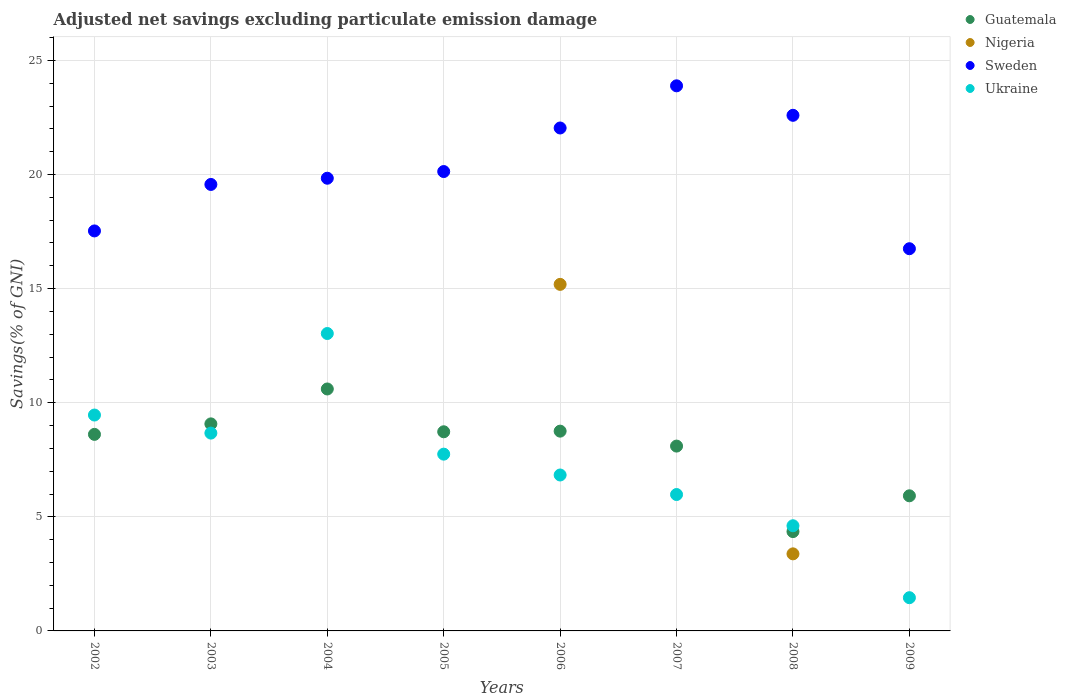Is the number of dotlines equal to the number of legend labels?
Offer a terse response. No. What is the adjusted net savings in Ukraine in 2009?
Your answer should be compact. 1.46. Across all years, what is the maximum adjusted net savings in Guatemala?
Ensure brevity in your answer.  10.6. Across all years, what is the minimum adjusted net savings in Sweden?
Your response must be concise. 16.75. In which year was the adjusted net savings in Sweden maximum?
Offer a very short reply. 2007. What is the total adjusted net savings in Sweden in the graph?
Keep it short and to the point. 162.33. What is the difference between the adjusted net savings in Sweden in 2006 and that in 2007?
Give a very brief answer. -1.85. What is the difference between the adjusted net savings in Nigeria in 2004 and the adjusted net savings in Guatemala in 2009?
Your answer should be very brief. -5.92. What is the average adjusted net savings in Sweden per year?
Ensure brevity in your answer.  20.29. In the year 2004, what is the difference between the adjusted net savings in Guatemala and adjusted net savings in Sweden?
Provide a short and direct response. -9.24. In how many years, is the adjusted net savings in Nigeria greater than 4 %?
Make the answer very short. 1. What is the ratio of the adjusted net savings in Sweden in 2003 to that in 2008?
Your answer should be very brief. 0.87. Is the adjusted net savings in Ukraine in 2003 less than that in 2008?
Offer a very short reply. No. What is the difference between the highest and the second highest adjusted net savings in Ukraine?
Give a very brief answer. 3.57. What is the difference between the highest and the lowest adjusted net savings in Ukraine?
Your answer should be compact. 11.58. In how many years, is the adjusted net savings in Guatemala greater than the average adjusted net savings in Guatemala taken over all years?
Give a very brief answer. 6. Is the adjusted net savings in Ukraine strictly greater than the adjusted net savings in Sweden over the years?
Offer a very short reply. No. How many years are there in the graph?
Your answer should be very brief. 8. What is the difference between two consecutive major ticks on the Y-axis?
Your response must be concise. 5. Does the graph contain any zero values?
Provide a short and direct response. Yes. Does the graph contain grids?
Ensure brevity in your answer.  Yes. Where does the legend appear in the graph?
Your answer should be very brief. Top right. What is the title of the graph?
Make the answer very short. Adjusted net savings excluding particulate emission damage. Does "High income: nonOECD" appear as one of the legend labels in the graph?
Your response must be concise. No. What is the label or title of the X-axis?
Provide a succinct answer. Years. What is the label or title of the Y-axis?
Provide a succinct answer. Savings(% of GNI). What is the Savings(% of GNI) of Guatemala in 2002?
Offer a very short reply. 8.61. What is the Savings(% of GNI) of Nigeria in 2002?
Provide a succinct answer. 0. What is the Savings(% of GNI) of Sweden in 2002?
Give a very brief answer. 17.53. What is the Savings(% of GNI) in Ukraine in 2002?
Your answer should be compact. 9.46. What is the Savings(% of GNI) of Guatemala in 2003?
Keep it short and to the point. 9.07. What is the Savings(% of GNI) in Sweden in 2003?
Your answer should be very brief. 19.57. What is the Savings(% of GNI) in Ukraine in 2003?
Give a very brief answer. 8.67. What is the Savings(% of GNI) of Guatemala in 2004?
Ensure brevity in your answer.  10.6. What is the Savings(% of GNI) in Sweden in 2004?
Provide a succinct answer. 19.84. What is the Savings(% of GNI) of Ukraine in 2004?
Your answer should be very brief. 13.03. What is the Savings(% of GNI) of Guatemala in 2005?
Provide a succinct answer. 8.73. What is the Savings(% of GNI) of Nigeria in 2005?
Your answer should be compact. 0. What is the Savings(% of GNI) of Sweden in 2005?
Offer a terse response. 20.13. What is the Savings(% of GNI) of Ukraine in 2005?
Provide a short and direct response. 7.75. What is the Savings(% of GNI) of Guatemala in 2006?
Ensure brevity in your answer.  8.75. What is the Savings(% of GNI) in Nigeria in 2006?
Offer a terse response. 15.19. What is the Savings(% of GNI) of Sweden in 2006?
Keep it short and to the point. 22.04. What is the Savings(% of GNI) in Ukraine in 2006?
Make the answer very short. 6.83. What is the Savings(% of GNI) in Guatemala in 2007?
Your response must be concise. 8.1. What is the Savings(% of GNI) of Nigeria in 2007?
Offer a very short reply. 0. What is the Savings(% of GNI) of Sweden in 2007?
Offer a terse response. 23.89. What is the Savings(% of GNI) of Ukraine in 2007?
Make the answer very short. 5.98. What is the Savings(% of GNI) in Guatemala in 2008?
Offer a terse response. 4.35. What is the Savings(% of GNI) in Nigeria in 2008?
Ensure brevity in your answer.  3.38. What is the Savings(% of GNI) of Sweden in 2008?
Your answer should be compact. 22.6. What is the Savings(% of GNI) of Ukraine in 2008?
Provide a short and direct response. 4.61. What is the Savings(% of GNI) of Guatemala in 2009?
Your answer should be compact. 5.92. What is the Savings(% of GNI) of Sweden in 2009?
Keep it short and to the point. 16.75. What is the Savings(% of GNI) in Ukraine in 2009?
Provide a short and direct response. 1.46. Across all years, what is the maximum Savings(% of GNI) in Guatemala?
Offer a very short reply. 10.6. Across all years, what is the maximum Savings(% of GNI) of Nigeria?
Make the answer very short. 15.19. Across all years, what is the maximum Savings(% of GNI) of Sweden?
Offer a terse response. 23.89. Across all years, what is the maximum Savings(% of GNI) of Ukraine?
Keep it short and to the point. 13.03. Across all years, what is the minimum Savings(% of GNI) of Guatemala?
Your answer should be very brief. 4.35. Across all years, what is the minimum Savings(% of GNI) of Sweden?
Provide a short and direct response. 16.75. Across all years, what is the minimum Savings(% of GNI) in Ukraine?
Offer a terse response. 1.46. What is the total Savings(% of GNI) of Guatemala in the graph?
Keep it short and to the point. 64.14. What is the total Savings(% of GNI) of Nigeria in the graph?
Offer a terse response. 18.56. What is the total Savings(% of GNI) of Sweden in the graph?
Your response must be concise. 162.33. What is the total Savings(% of GNI) of Ukraine in the graph?
Your answer should be compact. 57.78. What is the difference between the Savings(% of GNI) in Guatemala in 2002 and that in 2003?
Your answer should be very brief. -0.46. What is the difference between the Savings(% of GNI) in Sweden in 2002 and that in 2003?
Keep it short and to the point. -2.04. What is the difference between the Savings(% of GNI) in Ukraine in 2002 and that in 2003?
Your answer should be very brief. 0.79. What is the difference between the Savings(% of GNI) in Guatemala in 2002 and that in 2004?
Provide a succinct answer. -1.99. What is the difference between the Savings(% of GNI) of Sweden in 2002 and that in 2004?
Give a very brief answer. -2.31. What is the difference between the Savings(% of GNI) of Ukraine in 2002 and that in 2004?
Provide a succinct answer. -3.57. What is the difference between the Savings(% of GNI) in Guatemala in 2002 and that in 2005?
Give a very brief answer. -0.11. What is the difference between the Savings(% of GNI) of Sweden in 2002 and that in 2005?
Provide a short and direct response. -2.6. What is the difference between the Savings(% of GNI) of Ukraine in 2002 and that in 2005?
Offer a very short reply. 1.71. What is the difference between the Savings(% of GNI) of Guatemala in 2002 and that in 2006?
Offer a terse response. -0.14. What is the difference between the Savings(% of GNI) in Sweden in 2002 and that in 2006?
Make the answer very short. -4.51. What is the difference between the Savings(% of GNI) in Ukraine in 2002 and that in 2006?
Provide a short and direct response. 2.63. What is the difference between the Savings(% of GNI) in Guatemala in 2002 and that in 2007?
Provide a succinct answer. 0.51. What is the difference between the Savings(% of GNI) of Sweden in 2002 and that in 2007?
Your response must be concise. -6.36. What is the difference between the Savings(% of GNI) of Ukraine in 2002 and that in 2007?
Keep it short and to the point. 3.48. What is the difference between the Savings(% of GNI) of Guatemala in 2002 and that in 2008?
Your response must be concise. 4.26. What is the difference between the Savings(% of GNI) of Sweden in 2002 and that in 2008?
Offer a terse response. -5.07. What is the difference between the Savings(% of GNI) of Ukraine in 2002 and that in 2008?
Your answer should be very brief. 4.85. What is the difference between the Savings(% of GNI) of Guatemala in 2002 and that in 2009?
Your answer should be very brief. 2.69. What is the difference between the Savings(% of GNI) of Sweden in 2002 and that in 2009?
Your response must be concise. 0.78. What is the difference between the Savings(% of GNI) of Ukraine in 2002 and that in 2009?
Provide a succinct answer. 8. What is the difference between the Savings(% of GNI) in Guatemala in 2003 and that in 2004?
Give a very brief answer. -1.53. What is the difference between the Savings(% of GNI) in Sweden in 2003 and that in 2004?
Offer a terse response. -0.27. What is the difference between the Savings(% of GNI) of Ukraine in 2003 and that in 2004?
Offer a terse response. -4.36. What is the difference between the Savings(% of GNI) of Guatemala in 2003 and that in 2005?
Provide a short and direct response. 0.35. What is the difference between the Savings(% of GNI) in Sweden in 2003 and that in 2005?
Provide a succinct answer. -0.57. What is the difference between the Savings(% of GNI) of Ukraine in 2003 and that in 2005?
Your response must be concise. 0.92. What is the difference between the Savings(% of GNI) of Guatemala in 2003 and that in 2006?
Offer a terse response. 0.32. What is the difference between the Savings(% of GNI) of Sweden in 2003 and that in 2006?
Your answer should be very brief. -2.47. What is the difference between the Savings(% of GNI) of Ukraine in 2003 and that in 2006?
Provide a short and direct response. 1.84. What is the difference between the Savings(% of GNI) in Guatemala in 2003 and that in 2007?
Keep it short and to the point. 0.97. What is the difference between the Savings(% of GNI) in Sweden in 2003 and that in 2007?
Give a very brief answer. -4.32. What is the difference between the Savings(% of GNI) in Ukraine in 2003 and that in 2007?
Your answer should be compact. 2.69. What is the difference between the Savings(% of GNI) in Guatemala in 2003 and that in 2008?
Your response must be concise. 4.72. What is the difference between the Savings(% of GNI) of Sweden in 2003 and that in 2008?
Your answer should be very brief. -3.03. What is the difference between the Savings(% of GNI) of Ukraine in 2003 and that in 2008?
Offer a very short reply. 4.06. What is the difference between the Savings(% of GNI) in Guatemala in 2003 and that in 2009?
Provide a short and direct response. 3.15. What is the difference between the Savings(% of GNI) of Sweden in 2003 and that in 2009?
Your answer should be compact. 2.82. What is the difference between the Savings(% of GNI) in Ukraine in 2003 and that in 2009?
Your response must be concise. 7.21. What is the difference between the Savings(% of GNI) in Guatemala in 2004 and that in 2005?
Make the answer very short. 1.88. What is the difference between the Savings(% of GNI) in Sweden in 2004 and that in 2005?
Your answer should be very brief. -0.29. What is the difference between the Savings(% of GNI) of Ukraine in 2004 and that in 2005?
Provide a short and direct response. 5.29. What is the difference between the Savings(% of GNI) in Guatemala in 2004 and that in 2006?
Give a very brief answer. 1.85. What is the difference between the Savings(% of GNI) of Sweden in 2004 and that in 2006?
Offer a terse response. -2.2. What is the difference between the Savings(% of GNI) in Ukraine in 2004 and that in 2006?
Give a very brief answer. 6.2. What is the difference between the Savings(% of GNI) of Guatemala in 2004 and that in 2007?
Your answer should be compact. 2.5. What is the difference between the Savings(% of GNI) in Sweden in 2004 and that in 2007?
Ensure brevity in your answer.  -4.05. What is the difference between the Savings(% of GNI) in Ukraine in 2004 and that in 2007?
Your response must be concise. 7.06. What is the difference between the Savings(% of GNI) in Guatemala in 2004 and that in 2008?
Your response must be concise. 6.25. What is the difference between the Savings(% of GNI) in Sweden in 2004 and that in 2008?
Offer a very short reply. -2.76. What is the difference between the Savings(% of GNI) in Ukraine in 2004 and that in 2008?
Your answer should be very brief. 8.42. What is the difference between the Savings(% of GNI) in Guatemala in 2004 and that in 2009?
Your response must be concise. 4.68. What is the difference between the Savings(% of GNI) of Sweden in 2004 and that in 2009?
Ensure brevity in your answer.  3.09. What is the difference between the Savings(% of GNI) in Ukraine in 2004 and that in 2009?
Your answer should be very brief. 11.58. What is the difference between the Savings(% of GNI) in Guatemala in 2005 and that in 2006?
Your answer should be very brief. -0.03. What is the difference between the Savings(% of GNI) of Sweden in 2005 and that in 2006?
Keep it short and to the point. -1.91. What is the difference between the Savings(% of GNI) of Ukraine in 2005 and that in 2006?
Make the answer very short. 0.91. What is the difference between the Savings(% of GNI) of Guatemala in 2005 and that in 2007?
Provide a succinct answer. 0.63. What is the difference between the Savings(% of GNI) in Sweden in 2005 and that in 2007?
Make the answer very short. -3.76. What is the difference between the Savings(% of GNI) in Ukraine in 2005 and that in 2007?
Make the answer very short. 1.77. What is the difference between the Savings(% of GNI) in Guatemala in 2005 and that in 2008?
Your answer should be compact. 4.37. What is the difference between the Savings(% of GNI) of Sweden in 2005 and that in 2008?
Your response must be concise. -2.46. What is the difference between the Savings(% of GNI) of Ukraine in 2005 and that in 2008?
Your answer should be very brief. 3.14. What is the difference between the Savings(% of GNI) in Guatemala in 2005 and that in 2009?
Your response must be concise. 2.81. What is the difference between the Savings(% of GNI) of Sweden in 2005 and that in 2009?
Your answer should be compact. 3.38. What is the difference between the Savings(% of GNI) of Ukraine in 2005 and that in 2009?
Give a very brief answer. 6.29. What is the difference between the Savings(% of GNI) in Guatemala in 2006 and that in 2007?
Ensure brevity in your answer.  0.65. What is the difference between the Savings(% of GNI) in Sweden in 2006 and that in 2007?
Offer a terse response. -1.85. What is the difference between the Savings(% of GNI) in Ukraine in 2006 and that in 2007?
Make the answer very short. 0.86. What is the difference between the Savings(% of GNI) of Guatemala in 2006 and that in 2008?
Provide a succinct answer. 4.4. What is the difference between the Savings(% of GNI) in Nigeria in 2006 and that in 2008?
Provide a short and direct response. 11.81. What is the difference between the Savings(% of GNI) in Sweden in 2006 and that in 2008?
Your response must be concise. -0.56. What is the difference between the Savings(% of GNI) of Ukraine in 2006 and that in 2008?
Offer a very short reply. 2.22. What is the difference between the Savings(% of GNI) of Guatemala in 2006 and that in 2009?
Your answer should be compact. 2.83. What is the difference between the Savings(% of GNI) in Sweden in 2006 and that in 2009?
Offer a very short reply. 5.29. What is the difference between the Savings(% of GNI) in Ukraine in 2006 and that in 2009?
Your answer should be very brief. 5.38. What is the difference between the Savings(% of GNI) in Guatemala in 2007 and that in 2008?
Keep it short and to the point. 3.75. What is the difference between the Savings(% of GNI) of Sweden in 2007 and that in 2008?
Provide a succinct answer. 1.29. What is the difference between the Savings(% of GNI) in Ukraine in 2007 and that in 2008?
Provide a succinct answer. 1.37. What is the difference between the Savings(% of GNI) of Guatemala in 2007 and that in 2009?
Your answer should be compact. 2.18. What is the difference between the Savings(% of GNI) in Sweden in 2007 and that in 2009?
Offer a terse response. 7.14. What is the difference between the Savings(% of GNI) in Ukraine in 2007 and that in 2009?
Give a very brief answer. 4.52. What is the difference between the Savings(% of GNI) in Guatemala in 2008 and that in 2009?
Your response must be concise. -1.57. What is the difference between the Savings(% of GNI) of Sweden in 2008 and that in 2009?
Your answer should be compact. 5.85. What is the difference between the Savings(% of GNI) in Ukraine in 2008 and that in 2009?
Give a very brief answer. 3.15. What is the difference between the Savings(% of GNI) in Guatemala in 2002 and the Savings(% of GNI) in Sweden in 2003?
Provide a succinct answer. -10.95. What is the difference between the Savings(% of GNI) in Guatemala in 2002 and the Savings(% of GNI) in Ukraine in 2003?
Your answer should be very brief. -0.06. What is the difference between the Savings(% of GNI) in Sweden in 2002 and the Savings(% of GNI) in Ukraine in 2003?
Keep it short and to the point. 8.86. What is the difference between the Savings(% of GNI) of Guatemala in 2002 and the Savings(% of GNI) of Sweden in 2004?
Keep it short and to the point. -11.22. What is the difference between the Savings(% of GNI) in Guatemala in 2002 and the Savings(% of GNI) in Ukraine in 2004?
Provide a short and direct response. -4.42. What is the difference between the Savings(% of GNI) in Sweden in 2002 and the Savings(% of GNI) in Ukraine in 2004?
Your answer should be very brief. 4.5. What is the difference between the Savings(% of GNI) in Guatemala in 2002 and the Savings(% of GNI) in Sweden in 2005?
Keep it short and to the point. -11.52. What is the difference between the Savings(% of GNI) in Guatemala in 2002 and the Savings(% of GNI) in Ukraine in 2005?
Offer a terse response. 0.87. What is the difference between the Savings(% of GNI) of Sweden in 2002 and the Savings(% of GNI) of Ukraine in 2005?
Provide a short and direct response. 9.78. What is the difference between the Savings(% of GNI) of Guatemala in 2002 and the Savings(% of GNI) of Nigeria in 2006?
Your answer should be compact. -6.57. What is the difference between the Savings(% of GNI) of Guatemala in 2002 and the Savings(% of GNI) of Sweden in 2006?
Give a very brief answer. -13.43. What is the difference between the Savings(% of GNI) of Guatemala in 2002 and the Savings(% of GNI) of Ukraine in 2006?
Offer a terse response. 1.78. What is the difference between the Savings(% of GNI) in Sweden in 2002 and the Savings(% of GNI) in Ukraine in 2006?
Offer a very short reply. 10.7. What is the difference between the Savings(% of GNI) in Guatemala in 2002 and the Savings(% of GNI) in Sweden in 2007?
Provide a short and direct response. -15.27. What is the difference between the Savings(% of GNI) of Guatemala in 2002 and the Savings(% of GNI) of Ukraine in 2007?
Provide a short and direct response. 2.64. What is the difference between the Savings(% of GNI) in Sweden in 2002 and the Savings(% of GNI) in Ukraine in 2007?
Offer a very short reply. 11.55. What is the difference between the Savings(% of GNI) in Guatemala in 2002 and the Savings(% of GNI) in Nigeria in 2008?
Your answer should be very brief. 5.24. What is the difference between the Savings(% of GNI) of Guatemala in 2002 and the Savings(% of GNI) of Sweden in 2008?
Make the answer very short. -13.98. What is the difference between the Savings(% of GNI) of Guatemala in 2002 and the Savings(% of GNI) of Ukraine in 2008?
Offer a very short reply. 4. What is the difference between the Savings(% of GNI) of Sweden in 2002 and the Savings(% of GNI) of Ukraine in 2008?
Your answer should be compact. 12.92. What is the difference between the Savings(% of GNI) of Guatemala in 2002 and the Savings(% of GNI) of Sweden in 2009?
Keep it short and to the point. -8.14. What is the difference between the Savings(% of GNI) of Guatemala in 2002 and the Savings(% of GNI) of Ukraine in 2009?
Make the answer very short. 7.16. What is the difference between the Savings(% of GNI) of Sweden in 2002 and the Savings(% of GNI) of Ukraine in 2009?
Make the answer very short. 16.07. What is the difference between the Savings(% of GNI) of Guatemala in 2003 and the Savings(% of GNI) of Sweden in 2004?
Provide a succinct answer. -10.76. What is the difference between the Savings(% of GNI) of Guatemala in 2003 and the Savings(% of GNI) of Ukraine in 2004?
Your answer should be very brief. -3.96. What is the difference between the Savings(% of GNI) in Sweden in 2003 and the Savings(% of GNI) in Ukraine in 2004?
Offer a very short reply. 6.53. What is the difference between the Savings(% of GNI) of Guatemala in 2003 and the Savings(% of GNI) of Sweden in 2005?
Your answer should be compact. -11.06. What is the difference between the Savings(% of GNI) in Guatemala in 2003 and the Savings(% of GNI) in Ukraine in 2005?
Keep it short and to the point. 1.33. What is the difference between the Savings(% of GNI) of Sweden in 2003 and the Savings(% of GNI) of Ukraine in 2005?
Provide a succinct answer. 11.82. What is the difference between the Savings(% of GNI) in Guatemala in 2003 and the Savings(% of GNI) in Nigeria in 2006?
Give a very brief answer. -6.11. What is the difference between the Savings(% of GNI) in Guatemala in 2003 and the Savings(% of GNI) in Sweden in 2006?
Keep it short and to the point. -12.97. What is the difference between the Savings(% of GNI) of Guatemala in 2003 and the Savings(% of GNI) of Ukraine in 2006?
Offer a very short reply. 2.24. What is the difference between the Savings(% of GNI) in Sweden in 2003 and the Savings(% of GNI) in Ukraine in 2006?
Provide a succinct answer. 12.73. What is the difference between the Savings(% of GNI) in Guatemala in 2003 and the Savings(% of GNI) in Sweden in 2007?
Give a very brief answer. -14.81. What is the difference between the Savings(% of GNI) of Guatemala in 2003 and the Savings(% of GNI) of Ukraine in 2007?
Offer a terse response. 3.1. What is the difference between the Savings(% of GNI) of Sweden in 2003 and the Savings(% of GNI) of Ukraine in 2007?
Offer a very short reply. 13.59. What is the difference between the Savings(% of GNI) in Guatemala in 2003 and the Savings(% of GNI) in Nigeria in 2008?
Your answer should be very brief. 5.7. What is the difference between the Savings(% of GNI) of Guatemala in 2003 and the Savings(% of GNI) of Sweden in 2008?
Your answer should be compact. -13.52. What is the difference between the Savings(% of GNI) of Guatemala in 2003 and the Savings(% of GNI) of Ukraine in 2008?
Your response must be concise. 4.46. What is the difference between the Savings(% of GNI) of Sweden in 2003 and the Savings(% of GNI) of Ukraine in 2008?
Your response must be concise. 14.96. What is the difference between the Savings(% of GNI) of Guatemala in 2003 and the Savings(% of GNI) of Sweden in 2009?
Ensure brevity in your answer.  -7.68. What is the difference between the Savings(% of GNI) in Guatemala in 2003 and the Savings(% of GNI) in Ukraine in 2009?
Keep it short and to the point. 7.62. What is the difference between the Savings(% of GNI) in Sweden in 2003 and the Savings(% of GNI) in Ukraine in 2009?
Your response must be concise. 18.11. What is the difference between the Savings(% of GNI) of Guatemala in 2004 and the Savings(% of GNI) of Sweden in 2005?
Give a very brief answer. -9.53. What is the difference between the Savings(% of GNI) in Guatemala in 2004 and the Savings(% of GNI) in Ukraine in 2005?
Give a very brief answer. 2.86. What is the difference between the Savings(% of GNI) in Sweden in 2004 and the Savings(% of GNI) in Ukraine in 2005?
Ensure brevity in your answer.  12.09. What is the difference between the Savings(% of GNI) of Guatemala in 2004 and the Savings(% of GNI) of Nigeria in 2006?
Give a very brief answer. -4.58. What is the difference between the Savings(% of GNI) of Guatemala in 2004 and the Savings(% of GNI) of Sweden in 2006?
Ensure brevity in your answer.  -11.44. What is the difference between the Savings(% of GNI) in Guatemala in 2004 and the Savings(% of GNI) in Ukraine in 2006?
Offer a terse response. 3.77. What is the difference between the Savings(% of GNI) of Sweden in 2004 and the Savings(% of GNI) of Ukraine in 2006?
Offer a terse response. 13.01. What is the difference between the Savings(% of GNI) in Guatemala in 2004 and the Savings(% of GNI) in Sweden in 2007?
Give a very brief answer. -13.29. What is the difference between the Savings(% of GNI) in Guatemala in 2004 and the Savings(% of GNI) in Ukraine in 2007?
Offer a terse response. 4.63. What is the difference between the Savings(% of GNI) in Sweden in 2004 and the Savings(% of GNI) in Ukraine in 2007?
Your answer should be compact. 13.86. What is the difference between the Savings(% of GNI) in Guatemala in 2004 and the Savings(% of GNI) in Nigeria in 2008?
Make the answer very short. 7.23. What is the difference between the Savings(% of GNI) of Guatemala in 2004 and the Savings(% of GNI) of Sweden in 2008?
Your answer should be compact. -11.99. What is the difference between the Savings(% of GNI) in Guatemala in 2004 and the Savings(% of GNI) in Ukraine in 2008?
Keep it short and to the point. 5.99. What is the difference between the Savings(% of GNI) in Sweden in 2004 and the Savings(% of GNI) in Ukraine in 2008?
Make the answer very short. 15.23. What is the difference between the Savings(% of GNI) of Guatemala in 2004 and the Savings(% of GNI) of Sweden in 2009?
Provide a short and direct response. -6.15. What is the difference between the Savings(% of GNI) of Guatemala in 2004 and the Savings(% of GNI) of Ukraine in 2009?
Provide a succinct answer. 9.15. What is the difference between the Savings(% of GNI) in Sweden in 2004 and the Savings(% of GNI) in Ukraine in 2009?
Give a very brief answer. 18.38. What is the difference between the Savings(% of GNI) of Guatemala in 2005 and the Savings(% of GNI) of Nigeria in 2006?
Your response must be concise. -6.46. What is the difference between the Savings(% of GNI) of Guatemala in 2005 and the Savings(% of GNI) of Sweden in 2006?
Give a very brief answer. -13.31. What is the difference between the Savings(% of GNI) in Guatemala in 2005 and the Savings(% of GNI) in Ukraine in 2006?
Give a very brief answer. 1.89. What is the difference between the Savings(% of GNI) of Sweden in 2005 and the Savings(% of GNI) of Ukraine in 2006?
Your answer should be compact. 13.3. What is the difference between the Savings(% of GNI) of Guatemala in 2005 and the Savings(% of GNI) of Sweden in 2007?
Your answer should be very brief. -15.16. What is the difference between the Savings(% of GNI) in Guatemala in 2005 and the Savings(% of GNI) in Ukraine in 2007?
Offer a very short reply. 2.75. What is the difference between the Savings(% of GNI) in Sweden in 2005 and the Savings(% of GNI) in Ukraine in 2007?
Make the answer very short. 14.15. What is the difference between the Savings(% of GNI) in Guatemala in 2005 and the Savings(% of GNI) in Nigeria in 2008?
Your answer should be compact. 5.35. What is the difference between the Savings(% of GNI) in Guatemala in 2005 and the Savings(% of GNI) in Sweden in 2008?
Provide a succinct answer. -13.87. What is the difference between the Savings(% of GNI) of Guatemala in 2005 and the Savings(% of GNI) of Ukraine in 2008?
Your answer should be compact. 4.12. What is the difference between the Savings(% of GNI) in Sweden in 2005 and the Savings(% of GNI) in Ukraine in 2008?
Provide a short and direct response. 15.52. What is the difference between the Savings(% of GNI) of Guatemala in 2005 and the Savings(% of GNI) of Sweden in 2009?
Keep it short and to the point. -8.02. What is the difference between the Savings(% of GNI) in Guatemala in 2005 and the Savings(% of GNI) in Ukraine in 2009?
Give a very brief answer. 7.27. What is the difference between the Savings(% of GNI) of Sweden in 2005 and the Savings(% of GNI) of Ukraine in 2009?
Make the answer very short. 18.67. What is the difference between the Savings(% of GNI) of Guatemala in 2006 and the Savings(% of GNI) of Sweden in 2007?
Give a very brief answer. -15.13. What is the difference between the Savings(% of GNI) of Guatemala in 2006 and the Savings(% of GNI) of Ukraine in 2007?
Provide a short and direct response. 2.78. What is the difference between the Savings(% of GNI) in Nigeria in 2006 and the Savings(% of GNI) in Sweden in 2007?
Provide a succinct answer. -8.7. What is the difference between the Savings(% of GNI) of Nigeria in 2006 and the Savings(% of GNI) of Ukraine in 2007?
Offer a very short reply. 9.21. What is the difference between the Savings(% of GNI) in Sweden in 2006 and the Savings(% of GNI) in Ukraine in 2007?
Ensure brevity in your answer.  16.06. What is the difference between the Savings(% of GNI) in Guatemala in 2006 and the Savings(% of GNI) in Nigeria in 2008?
Offer a very short reply. 5.38. What is the difference between the Savings(% of GNI) in Guatemala in 2006 and the Savings(% of GNI) in Sweden in 2008?
Offer a very short reply. -13.84. What is the difference between the Savings(% of GNI) in Guatemala in 2006 and the Savings(% of GNI) in Ukraine in 2008?
Provide a succinct answer. 4.15. What is the difference between the Savings(% of GNI) in Nigeria in 2006 and the Savings(% of GNI) in Sweden in 2008?
Keep it short and to the point. -7.41. What is the difference between the Savings(% of GNI) of Nigeria in 2006 and the Savings(% of GNI) of Ukraine in 2008?
Offer a very short reply. 10.58. What is the difference between the Savings(% of GNI) in Sweden in 2006 and the Savings(% of GNI) in Ukraine in 2008?
Your response must be concise. 17.43. What is the difference between the Savings(% of GNI) in Guatemala in 2006 and the Savings(% of GNI) in Sweden in 2009?
Offer a very short reply. -7.99. What is the difference between the Savings(% of GNI) in Guatemala in 2006 and the Savings(% of GNI) in Ukraine in 2009?
Ensure brevity in your answer.  7.3. What is the difference between the Savings(% of GNI) in Nigeria in 2006 and the Savings(% of GNI) in Sweden in 2009?
Keep it short and to the point. -1.56. What is the difference between the Savings(% of GNI) of Nigeria in 2006 and the Savings(% of GNI) of Ukraine in 2009?
Give a very brief answer. 13.73. What is the difference between the Savings(% of GNI) of Sweden in 2006 and the Savings(% of GNI) of Ukraine in 2009?
Your response must be concise. 20.58. What is the difference between the Savings(% of GNI) in Guatemala in 2007 and the Savings(% of GNI) in Nigeria in 2008?
Your answer should be compact. 4.72. What is the difference between the Savings(% of GNI) in Guatemala in 2007 and the Savings(% of GNI) in Sweden in 2008?
Your answer should be compact. -14.5. What is the difference between the Savings(% of GNI) of Guatemala in 2007 and the Savings(% of GNI) of Ukraine in 2008?
Provide a succinct answer. 3.49. What is the difference between the Savings(% of GNI) in Sweden in 2007 and the Savings(% of GNI) in Ukraine in 2008?
Make the answer very short. 19.28. What is the difference between the Savings(% of GNI) of Guatemala in 2007 and the Savings(% of GNI) of Sweden in 2009?
Keep it short and to the point. -8.65. What is the difference between the Savings(% of GNI) in Guatemala in 2007 and the Savings(% of GNI) in Ukraine in 2009?
Make the answer very short. 6.64. What is the difference between the Savings(% of GNI) in Sweden in 2007 and the Savings(% of GNI) in Ukraine in 2009?
Offer a terse response. 22.43. What is the difference between the Savings(% of GNI) in Guatemala in 2008 and the Savings(% of GNI) in Sweden in 2009?
Provide a short and direct response. -12.4. What is the difference between the Savings(% of GNI) in Guatemala in 2008 and the Savings(% of GNI) in Ukraine in 2009?
Keep it short and to the point. 2.9. What is the difference between the Savings(% of GNI) in Nigeria in 2008 and the Savings(% of GNI) in Sweden in 2009?
Keep it short and to the point. -13.37. What is the difference between the Savings(% of GNI) in Nigeria in 2008 and the Savings(% of GNI) in Ukraine in 2009?
Give a very brief answer. 1.92. What is the difference between the Savings(% of GNI) in Sweden in 2008 and the Savings(% of GNI) in Ukraine in 2009?
Make the answer very short. 21.14. What is the average Savings(% of GNI) of Guatemala per year?
Offer a very short reply. 8.02. What is the average Savings(% of GNI) in Nigeria per year?
Your answer should be very brief. 2.32. What is the average Savings(% of GNI) in Sweden per year?
Keep it short and to the point. 20.29. What is the average Savings(% of GNI) in Ukraine per year?
Your answer should be very brief. 7.22. In the year 2002, what is the difference between the Savings(% of GNI) of Guatemala and Savings(% of GNI) of Sweden?
Offer a terse response. -8.92. In the year 2002, what is the difference between the Savings(% of GNI) of Guatemala and Savings(% of GNI) of Ukraine?
Your answer should be very brief. -0.85. In the year 2002, what is the difference between the Savings(% of GNI) of Sweden and Savings(% of GNI) of Ukraine?
Offer a terse response. 8.07. In the year 2003, what is the difference between the Savings(% of GNI) of Guatemala and Savings(% of GNI) of Sweden?
Keep it short and to the point. -10.49. In the year 2003, what is the difference between the Savings(% of GNI) of Guatemala and Savings(% of GNI) of Ukraine?
Your answer should be very brief. 0.4. In the year 2003, what is the difference between the Savings(% of GNI) in Sweden and Savings(% of GNI) in Ukraine?
Offer a terse response. 10.9. In the year 2004, what is the difference between the Savings(% of GNI) of Guatemala and Savings(% of GNI) of Sweden?
Offer a terse response. -9.24. In the year 2004, what is the difference between the Savings(% of GNI) of Guatemala and Savings(% of GNI) of Ukraine?
Make the answer very short. -2.43. In the year 2004, what is the difference between the Savings(% of GNI) of Sweden and Savings(% of GNI) of Ukraine?
Your response must be concise. 6.8. In the year 2005, what is the difference between the Savings(% of GNI) of Guatemala and Savings(% of GNI) of Sweden?
Provide a short and direct response. -11.4. In the year 2005, what is the difference between the Savings(% of GNI) of Guatemala and Savings(% of GNI) of Ukraine?
Your answer should be compact. 0.98. In the year 2005, what is the difference between the Savings(% of GNI) in Sweden and Savings(% of GNI) in Ukraine?
Give a very brief answer. 12.38. In the year 2006, what is the difference between the Savings(% of GNI) in Guatemala and Savings(% of GNI) in Nigeria?
Your response must be concise. -6.43. In the year 2006, what is the difference between the Savings(% of GNI) of Guatemala and Savings(% of GNI) of Sweden?
Your answer should be compact. -13.29. In the year 2006, what is the difference between the Savings(% of GNI) in Guatemala and Savings(% of GNI) in Ukraine?
Provide a short and direct response. 1.92. In the year 2006, what is the difference between the Savings(% of GNI) of Nigeria and Savings(% of GNI) of Sweden?
Your answer should be compact. -6.85. In the year 2006, what is the difference between the Savings(% of GNI) of Nigeria and Savings(% of GNI) of Ukraine?
Keep it short and to the point. 8.35. In the year 2006, what is the difference between the Savings(% of GNI) in Sweden and Savings(% of GNI) in Ukraine?
Your answer should be compact. 15.21. In the year 2007, what is the difference between the Savings(% of GNI) in Guatemala and Savings(% of GNI) in Sweden?
Your response must be concise. -15.79. In the year 2007, what is the difference between the Savings(% of GNI) in Guatemala and Savings(% of GNI) in Ukraine?
Provide a succinct answer. 2.12. In the year 2007, what is the difference between the Savings(% of GNI) of Sweden and Savings(% of GNI) of Ukraine?
Give a very brief answer. 17.91. In the year 2008, what is the difference between the Savings(% of GNI) of Guatemala and Savings(% of GNI) of Nigeria?
Make the answer very short. 0.98. In the year 2008, what is the difference between the Savings(% of GNI) in Guatemala and Savings(% of GNI) in Sweden?
Make the answer very short. -18.24. In the year 2008, what is the difference between the Savings(% of GNI) in Guatemala and Savings(% of GNI) in Ukraine?
Your answer should be very brief. -0.26. In the year 2008, what is the difference between the Savings(% of GNI) of Nigeria and Savings(% of GNI) of Sweden?
Give a very brief answer. -19.22. In the year 2008, what is the difference between the Savings(% of GNI) of Nigeria and Savings(% of GNI) of Ukraine?
Give a very brief answer. -1.23. In the year 2008, what is the difference between the Savings(% of GNI) of Sweden and Savings(% of GNI) of Ukraine?
Offer a terse response. 17.99. In the year 2009, what is the difference between the Savings(% of GNI) of Guatemala and Savings(% of GNI) of Sweden?
Your answer should be compact. -10.83. In the year 2009, what is the difference between the Savings(% of GNI) in Guatemala and Savings(% of GNI) in Ukraine?
Keep it short and to the point. 4.47. In the year 2009, what is the difference between the Savings(% of GNI) in Sweden and Savings(% of GNI) in Ukraine?
Offer a terse response. 15.29. What is the ratio of the Savings(% of GNI) in Guatemala in 2002 to that in 2003?
Offer a terse response. 0.95. What is the ratio of the Savings(% of GNI) of Sweden in 2002 to that in 2003?
Offer a very short reply. 0.9. What is the ratio of the Savings(% of GNI) of Ukraine in 2002 to that in 2003?
Give a very brief answer. 1.09. What is the ratio of the Savings(% of GNI) of Guatemala in 2002 to that in 2004?
Your answer should be compact. 0.81. What is the ratio of the Savings(% of GNI) in Sweden in 2002 to that in 2004?
Provide a short and direct response. 0.88. What is the ratio of the Savings(% of GNI) in Ukraine in 2002 to that in 2004?
Your answer should be compact. 0.73. What is the ratio of the Savings(% of GNI) of Guatemala in 2002 to that in 2005?
Provide a succinct answer. 0.99. What is the ratio of the Savings(% of GNI) in Sweden in 2002 to that in 2005?
Offer a terse response. 0.87. What is the ratio of the Savings(% of GNI) in Ukraine in 2002 to that in 2005?
Provide a short and direct response. 1.22. What is the ratio of the Savings(% of GNI) of Guatemala in 2002 to that in 2006?
Ensure brevity in your answer.  0.98. What is the ratio of the Savings(% of GNI) of Sweden in 2002 to that in 2006?
Offer a terse response. 0.8. What is the ratio of the Savings(% of GNI) of Ukraine in 2002 to that in 2006?
Provide a short and direct response. 1.38. What is the ratio of the Savings(% of GNI) of Guatemala in 2002 to that in 2007?
Offer a terse response. 1.06. What is the ratio of the Savings(% of GNI) in Sweden in 2002 to that in 2007?
Provide a succinct answer. 0.73. What is the ratio of the Savings(% of GNI) in Ukraine in 2002 to that in 2007?
Make the answer very short. 1.58. What is the ratio of the Savings(% of GNI) of Guatemala in 2002 to that in 2008?
Your response must be concise. 1.98. What is the ratio of the Savings(% of GNI) of Sweden in 2002 to that in 2008?
Your answer should be very brief. 0.78. What is the ratio of the Savings(% of GNI) in Ukraine in 2002 to that in 2008?
Keep it short and to the point. 2.05. What is the ratio of the Savings(% of GNI) in Guatemala in 2002 to that in 2009?
Offer a terse response. 1.45. What is the ratio of the Savings(% of GNI) in Sweden in 2002 to that in 2009?
Give a very brief answer. 1.05. What is the ratio of the Savings(% of GNI) of Ukraine in 2002 to that in 2009?
Ensure brevity in your answer.  6.5. What is the ratio of the Savings(% of GNI) of Guatemala in 2003 to that in 2004?
Give a very brief answer. 0.86. What is the ratio of the Savings(% of GNI) in Sweden in 2003 to that in 2004?
Make the answer very short. 0.99. What is the ratio of the Savings(% of GNI) in Ukraine in 2003 to that in 2004?
Offer a terse response. 0.67. What is the ratio of the Savings(% of GNI) in Guatemala in 2003 to that in 2005?
Your response must be concise. 1.04. What is the ratio of the Savings(% of GNI) in Sweden in 2003 to that in 2005?
Your answer should be compact. 0.97. What is the ratio of the Savings(% of GNI) of Ukraine in 2003 to that in 2005?
Make the answer very short. 1.12. What is the ratio of the Savings(% of GNI) in Guatemala in 2003 to that in 2006?
Your response must be concise. 1.04. What is the ratio of the Savings(% of GNI) in Sweden in 2003 to that in 2006?
Provide a short and direct response. 0.89. What is the ratio of the Savings(% of GNI) of Ukraine in 2003 to that in 2006?
Make the answer very short. 1.27. What is the ratio of the Savings(% of GNI) of Guatemala in 2003 to that in 2007?
Keep it short and to the point. 1.12. What is the ratio of the Savings(% of GNI) in Sweden in 2003 to that in 2007?
Keep it short and to the point. 0.82. What is the ratio of the Savings(% of GNI) in Ukraine in 2003 to that in 2007?
Give a very brief answer. 1.45. What is the ratio of the Savings(% of GNI) in Guatemala in 2003 to that in 2008?
Ensure brevity in your answer.  2.08. What is the ratio of the Savings(% of GNI) in Sweden in 2003 to that in 2008?
Make the answer very short. 0.87. What is the ratio of the Savings(% of GNI) in Ukraine in 2003 to that in 2008?
Offer a very short reply. 1.88. What is the ratio of the Savings(% of GNI) in Guatemala in 2003 to that in 2009?
Provide a succinct answer. 1.53. What is the ratio of the Savings(% of GNI) in Sweden in 2003 to that in 2009?
Offer a terse response. 1.17. What is the ratio of the Savings(% of GNI) in Ukraine in 2003 to that in 2009?
Keep it short and to the point. 5.95. What is the ratio of the Savings(% of GNI) of Guatemala in 2004 to that in 2005?
Offer a very short reply. 1.21. What is the ratio of the Savings(% of GNI) of Sweden in 2004 to that in 2005?
Your response must be concise. 0.99. What is the ratio of the Savings(% of GNI) of Ukraine in 2004 to that in 2005?
Give a very brief answer. 1.68. What is the ratio of the Savings(% of GNI) of Guatemala in 2004 to that in 2006?
Your answer should be very brief. 1.21. What is the ratio of the Savings(% of GNI) of Sweden in 2004 to that in 2006?
Keep it short and to the point. 0.9. What is the ratio of the Savings(% of GNI) of Ukraine in 2004 to that in 2006?
Your response must be concise. 1.91. What is the ratio of the Savings(% of GNI) in Guatemala in 2004 to that in 2007?
Make the answer very short. 1.31. What is the ratio of the Savings(% of GNI) of Sweden in 2004 to that in 2007?
Your answer should be compact. 0.83. What is the ratio of the Savings(% of GNI) of Ukraine in 2004 to that in 2007?
Offer a very short reply. 2.18. What is the ratio of the Savings(% of GNI) in Guatemala in 2004 to that in 2008?
Provide a succinct answer. 2.44. What is the ratio of the Savings(% of GNI) of Sweden in 2004 to that in 2008?
Provide a short and direct response. 0.88. What is the ratio of the Savings(% of GNI) in Ukraine in 2004 to that in 2008?
Your answer should be compact. 2.83. What is the ratio of the Savings(% of GNI) of Guatemala in 2004 to that in 2009?
Make the answer very short. 1.79. What is the ratio of the Savings(% of GNI) of Sweden in 2004 to that in 2009?
Provide a succinct answer. 1.18. What is the ratio of the Savings(% of GNI) of Ukraine in 2004 to that in 2009?
Your answer should be compact. 8.95. What is the ratio of the Savings(% of GNI) in Guatemala in 2005 to that in 2006?
Your answer should be very brief. 1. What is the ratio of the Savings(% of GNI) in Sweden in 2005 to that in 2006?
Ensure brevity in your answer.  0.91. What is the ratio of the Savings(% of GNI) in Ukraine in 2005 to that in 2006?
Your answer should be compact. 1.13. What is the ratio of the Savings(% of GNI) in Guatemala in 2005 to that in 2007?
Ensure brevity in your answer.  1.08. What is the ratio of the Savings(% of GNI) in Sweden in 2005 to that in 2007?
Your response must be concise. 0.84. What is the ratio of the Savings(% of GNI) in Ukraine in 2005 to that in 2007?
Provide a succinct answer. 1.3. What is the ratio of the Savings(% of GNI) in Guatemala in 2005 to that in 2008?
Your answer should be compact. 2.01. What is the ratio of the Savings(% of GNI) of Sweden in 2005 to that in 2008?
Provide a short and direct response. 0.89. What is the ratio of the Savings(% of GNI) of Ukraine in 2005 to that in 2008?
Keep it short and to the point. 1.68. What is the ratio of the Savings(% of GNI) of Guatemala in 2005 to that in 2009?
Keep it short and to the point. 1.47. What is the ratio of the Savings(% of GNI) of Sweden in 2005 to that in 2009?
Provide a succinct answer. 1.2. What is the ratio of the Savings(% of GNI) of Ukraine in 2005 to that in 2009?
Provide a short and direct response. 5.32. What is the ratio of the Savings(% of GNI) of Guatemala in 2006 to that in 2007?
Make the answer very short. 1.08. What is the ratio of the Savings(% of GNI) of Sweden in 2006 to that in 2007?
Give a very brief answer. 0.92. What is the ratio of the Savings(% of GNI) of Ukraine in 2006 to that in 2007?
Provide a short and direct response. 1.14. What is the ratio of the Savings(% of GNI) in Guatemala in 2006 to that in 2008?
Offer a terse response. 2.01. What is the ratio of the Savings(% of GNI) of Nigeria in 2006 to that in 2008?
Give a very brief answer. 4.5. What is the ratio of the Savings(% of GNI) in Sweden in 2006 to that in 2008?
Offer a very short reply. 0.98. What is the ratio of the Savings(% of GNI) in Ukraine in 2006 to that in 2008?
Provide a succinct answer. 1.48. What is the ratio of the Savings(% of GNI) in Guatemala in 2006 to that in 2009?
Ensure brevity in your answer.  1.48. What is the ratio of the Savings(% of GNI) of Sweden in 2006 to that in 2009?
Give a very brief answer. 1.32. What is the ratio of the Savings(% of GNI) in Ukraine in 2006 to that in 2009?
Provide a succinct answer. 4.69. What is the ratio of the Savings(% of GNI) in Guatemala in 2007 to that in 2008?
Keep it short and to the point. 1.86. What is the ratio of the Savings(% of GNI) of Sweden in 2007 to that in 2008?
Your response must be concise. 1.06. What is the ratio of the Savings(% of GNI) in Ukraine in 2007 to that in 2008?
Your response must be concise. 1.3. What is the ratio of the Savings(% of GNI) of Guatemala in 2007 to that in 2009?
Keep it short and to the point. 1.37. What is the ratio of the Savings(% of GNI) in Sweden in 2007 to that in 2009?
Make the answer very short. 1.43. What is the ratio of the Savings(% of GNI) of Ukraine in 2007 to that in 2009?
Provide a short and direct response. 4.11. What is the ratio of the Savings(% of GNI) of Guatemala in 2008 to that in 2009?
Your response must be concise. 0.74. What is the ratio of the Savings(% of GNI) of Sweden in 2008 to that in 2009?
Ensure brevity in your answer.  1.35. What is the ratio of the Savings(% of GNI) in Ukraine in 2008 to that in 2009?
Your answer should be compact. 3.17. What is the difference between the highest and the second highest Savings(% of GNI) in Guatemala?
Your answer should be very brief. 1.53. What is the difference between the highest and the second highest Savings(% of GNI) of Sweden?
Provide a succinct answer. 1.29. What is the difference between the highest and the second highest Savings(% of GNI) of Ukraine?
Your response must be concise. 3.57. What is the difference between the highest and the lowest Savings(% of GNI) of Guatemala?
Ensure brevity in your answer.  6.25. What is the difference between the highest and the lowest Savings(% of GNI) in Nigeria?
Your response must be concise. 15.19. What is the difference between the highest and the lowest Savings(% of GNI) in Sweden?
Offer a terse response. 7.14. What is the difference between the highest and the lowest Savings(% of GNI) of Ukraine?
Ensure brevity in your answer.  11.58. 